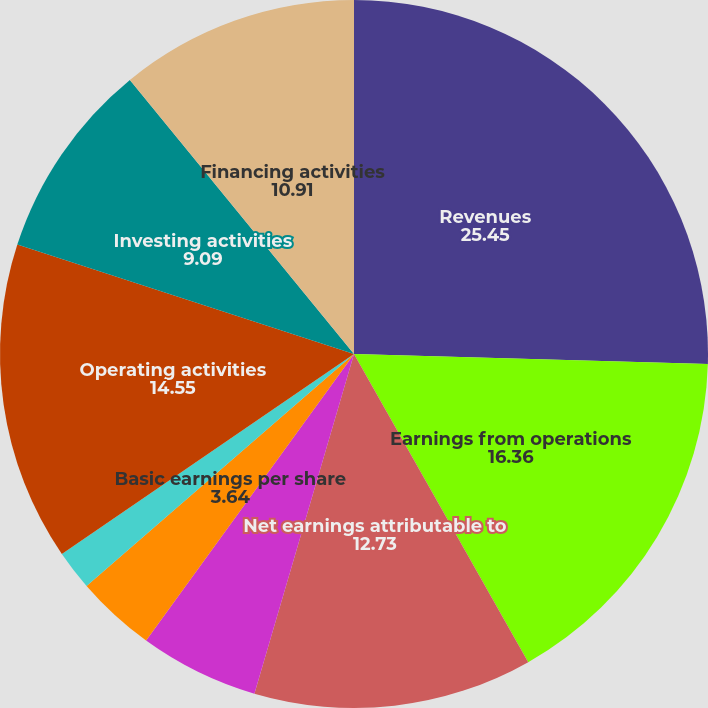Convert chart. <chart><loc_0><loc_0><loc_500><loc_500><pie_chart><fcel>Revenues<fcel>Earnings from operations<fcel>Net earnings attributable to<fcel>Return on equity (c)<fcel>Basic earnings per share<fcel>Diluted earnings per share<fcel>Cash dividends declared per<fcel>Operating activities<fcel>Investing activities<fcel>Financing activities<nl><fcel>25.45%<fcel>16.36%<fcel>12.73%<fcel>5.45%<fcel>3.64%<fcel>1.82%<fcel>0.0%<fcel>14.55%<fcel>9.09%<fcel>10.91%<nl></chart> 